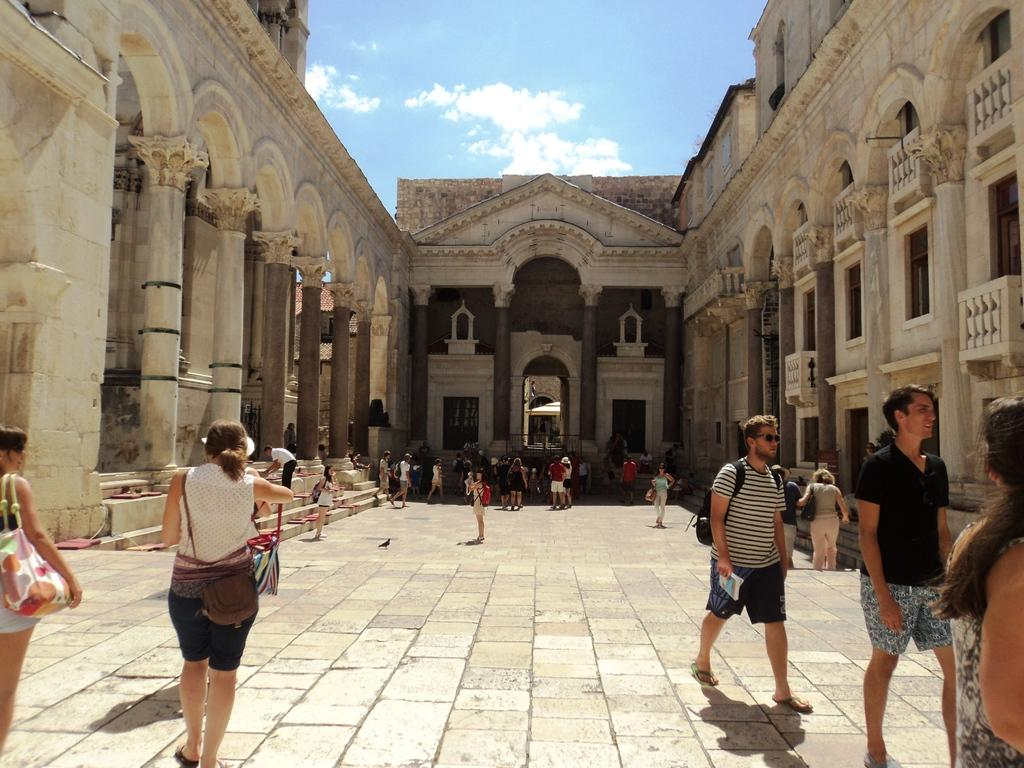What are the people in the image doing? The people in the image are walking on the floor. What can be seen in the background of the image? There is a monument in the background of the image. What is visible at the top of the image? The sky is visible at the top of the image. What can be observed in the sky? There are: There are clouds in the sky. What type of zinc is being used to construct the monument in the image? There is no mention of zinc being used in the construction of the monument in the image. The monument's material is not specified in the provided facts. 